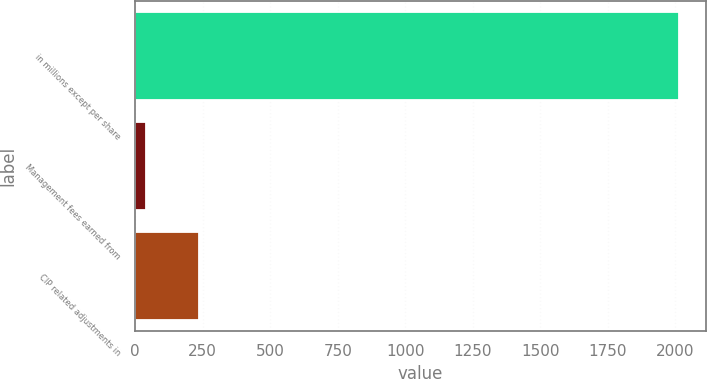Convert chart to OTSL. <chart><loc_0><loc_0><loc_500><loc_500><bar_chart><fcel>in millions except per share<fcel>Management fees earned from<fcel>CIP related adjustments in<nl><fcel>2012<fcel>38.6<fcel>235.94<nl></chart> 